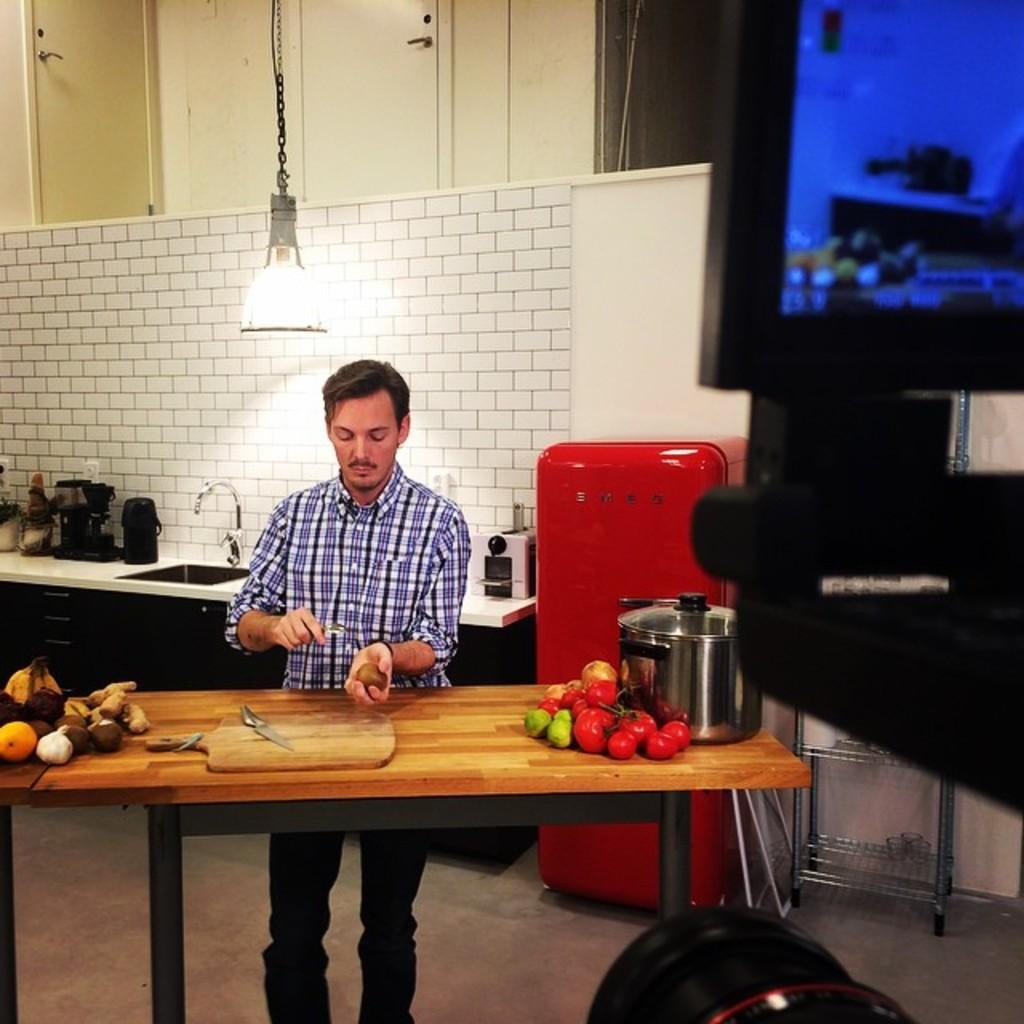What is the main subject of the image? There is a man standing in the image. Where is the man standing? The man is standing on the floor. What can be seen on the table in the image? There are fruits and a knife on the table. What is visible in the background of the image? There is a wall and light in the background of the image. What type of nut is being used to gain knowledge in the image? There is no nut or knowledge acquisition depicted in the image; it features a man standing on the floor with a table containing fruits and a knife in the background. 